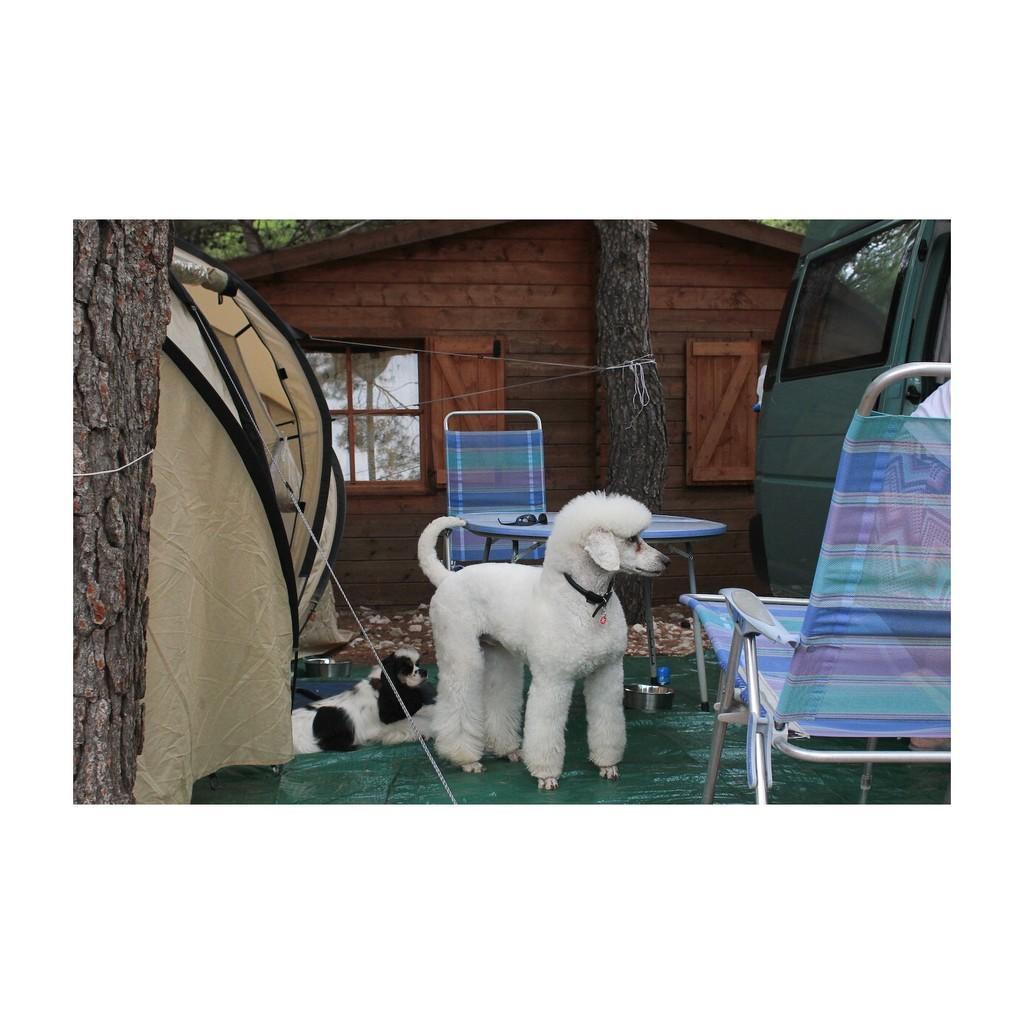Describe this image in one or two sentences. On the left side of the image there is a tree trunk. Beside the trunk there is a dog standing and there is another dog lying on the floor. Beside the dog there is a chair. Beside the chair there is a van. Behind the dog there is a table with goggles. Behind the table there is a chair. In the background there is a house with wall, window and tree trunk. 